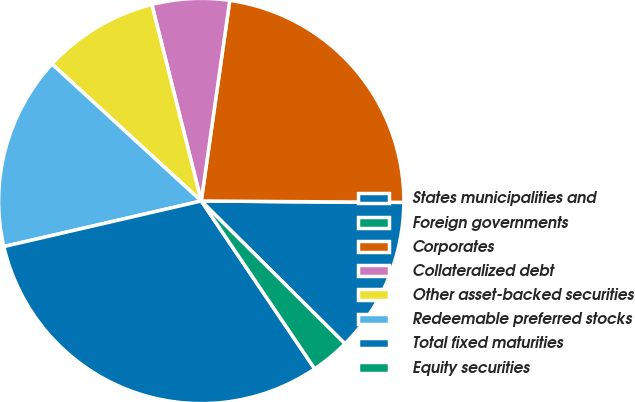Convert chart to OTSL. <chart><loc_0><loc_0><loc_500><loc_500><pie_chart><fcel>States municipalities and<fcel>Foreign governments<fcel>Corporates<fcel>Collateralized debt<fcel>Other asset-backed securities<fcel>Redeemable preferred stocks<fcel>Total fixed maturities<fcel>Equity securities<nl><fcel>12.34%<fcel>0.0%<fcel>22.86%<fcel>6.17%<fcel>9.26%<fcel>15.43%<fcel>30.85%<fcel>3.09%<nl></chart> 